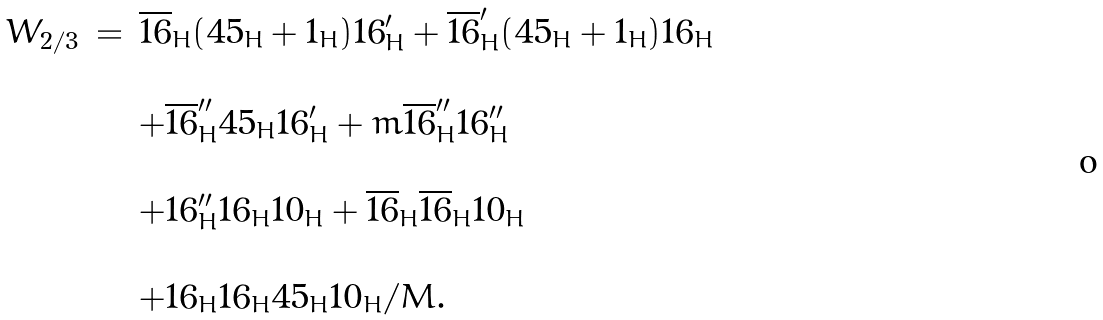<formula> <loc_0><loc_0><loc_500><loc_500>\begin{array} { c c l } W _ { 2 / 3 } & = & \overline { 1 6 } _ { H } ( { 4 5 } _ { H } + { 1 } _ { H } ) { 1 6 } ^ { \prime } _ { H } + \overline { 1 6 } ^ { \prime } _ { H } ( { 4 5 } _ { H } + { 1 } _ { H } ) { 1 6 } _ { H } \\ & & \\ & & + \overline { 1 6 } ^ { \prime \prime } _ { H } { 4 5 } _ { H } { 1 6 } ^ { \prime } _ { H } + m \overline { 1 6 } ^ { \prime \prime } _ { H } { 1 6 } ^ { \prime \prime } _ { H } \\ & & \\ & & + { 1 6 } ^ { \prime \prime } _ { H } { 1 6 } _ { H } { 1 0 } _ { H } + \overline { 1 6 } _ { H } \overline { 1 6 } _ { H } { 1 0 } _ { H } \\ & & \\ & & + { 1 6 } _ { H } { 1 6 } _ { H } { 4 5 } _ { H } { 1 0 } _ { H } / M . \end{array}</formula> 